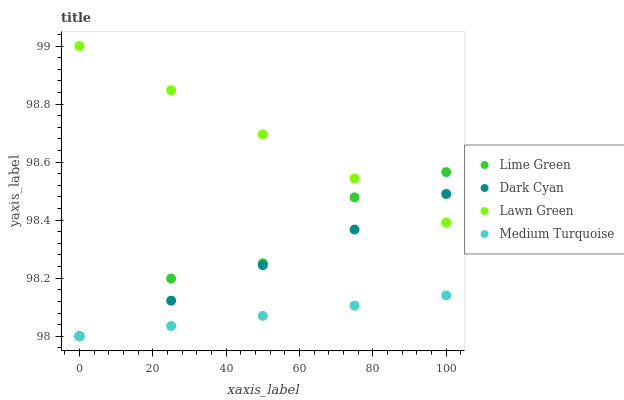Does Medium Turquoise have the minimum area under the curve?
Answer yes or no. Yes. Does Lawn Green have the maximum area under the curve?
Answer yes or no. Yes. Does Lime Green have the minimum area under the curve?
Answer yes or no. No. Does Lime Green have the maximum area under the curve?
Answer yes or no. No. Is Dark Cyan the smoothest?
Answer yes or no. Yes. Is Lime Green the roughest?
Answer yes or no. Yes. Is Lawn Green the smoothest?
Answer yes or no. No. Is Lawn Green the roughest?
Answer yes or no. No. Does Dark Cyan have the lowest value?
Answer yes or no. Yes. Does Lawn Green have the lowest value?
Answer yes or no. No. Does Lawn Green have the highest value?
Answer yes or no. Yes. Does Lime Green have the highest value?
Answer yes or no. No. Is Medium Turquoise less than Lawn Green?
Answer yes or no. Yes. Is Lawn Green greater than Medium Turquoise?
Answer yes or no. Yes. Does Lawn Green intersect Lime Green?
Answer yes or no. Yes. Is Lawn Green less than Lime Green?
Answer yes or no. No. Is Lawn Green greater than Lime Green?
Answer yes or no. No. Does Medium Turquoise intersect Lawn Green?
Answer yes or no. No. 